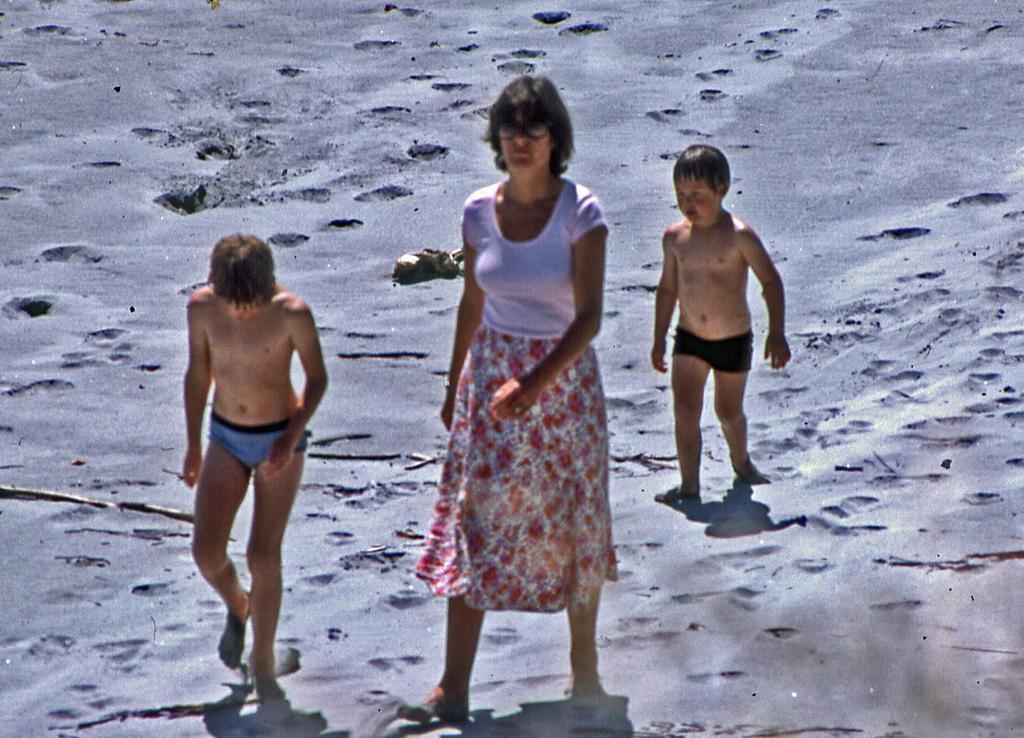Can you describe this image briefly? In this image we can see there are three people, one woman and two kids are walking on the sand. 